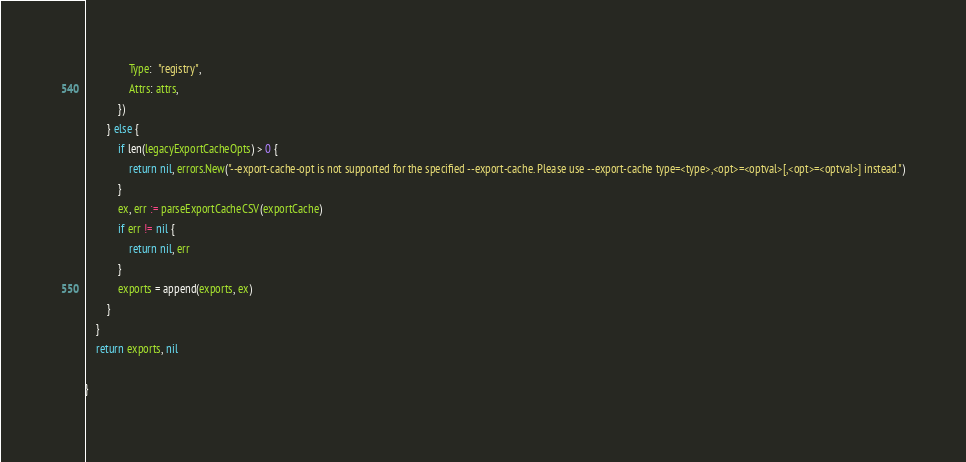<code> <loc_0><loc_0><loc_500><loc_500><_Go_>				Type:  "registry",
				Attrs: attrs,
			})
		} else {
			if len(legacyExportCacheOpts) > 0 {
				return nil, errors.New("--export-cache-opt is not supported for the specified --export-cache. Please use --export-cache type=<type>,<opt>=<optval>[,<opt>=<optval>] instead.")
			}
			ex, err := parseExportCacheCSV(exportCache)
			if err != nil {
				return nil, err
			}
			exports = append(exports, ex)
		}
	}
	return exports, nil

}
</code> 